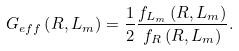<formula> <loc_0><loc_0><loc_500><loc_500>G _ { e f f } \left ( R , L _ { m } \right ) = \frac { 1 } { 2 } \frac { f _ { L _ { m } } \left ( R , L _ { m } \right ) } { f _ { R } \left ( R , L _ { m } \right ) } .</formula> 